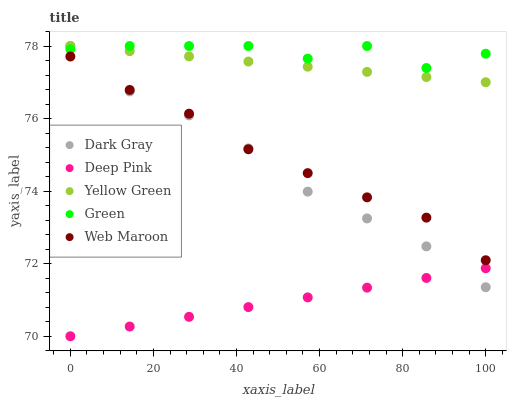Does Deep Pink have the minimum area under the curve?
Answer yes or no. Yes. Does Green have the maximum area under the curve?
Answer yes or no. Yes. Does Web Maroon have the minimum area under the curve?
Answer yes or no. No. Does Web Maroon have the maximum area under the curve?
Answer yes or no. No. Is Deep Pink the smoothest?
Answer yes or no. Yes. Is Green the roughest?
Answer yes or no. Yes. Is Web Maroon the smoothest?
Answer yes or no. No. Is Web Maroon the roughest?
Answer yes or no. No. Does Deep Pink have the lowest value?
Answer yes or no. Yes. Does Web Maroon have the lowest value?
Answer yes or no. No. Does Yellow Green have the highest value?
Answer yes or no. Yes. Does Web Maroon have the highest value?
Answer yes or no. No. Is Deep Pink less than Green?
Answer yes or no. Yes. Is Yellow Green greater than Deep Pink?
Answer yes or no. Yes. Does Dark Gray intersect Deep Pink?
Answer yes or no. Yes. Is Dark Gray less than Deep Pink?
Answer yes or no. No. Is Dark Gray greater than Deep Pink?
Answer yes or no. No. Does Deep Pink intersect Green?
Answer yes or no. No. 